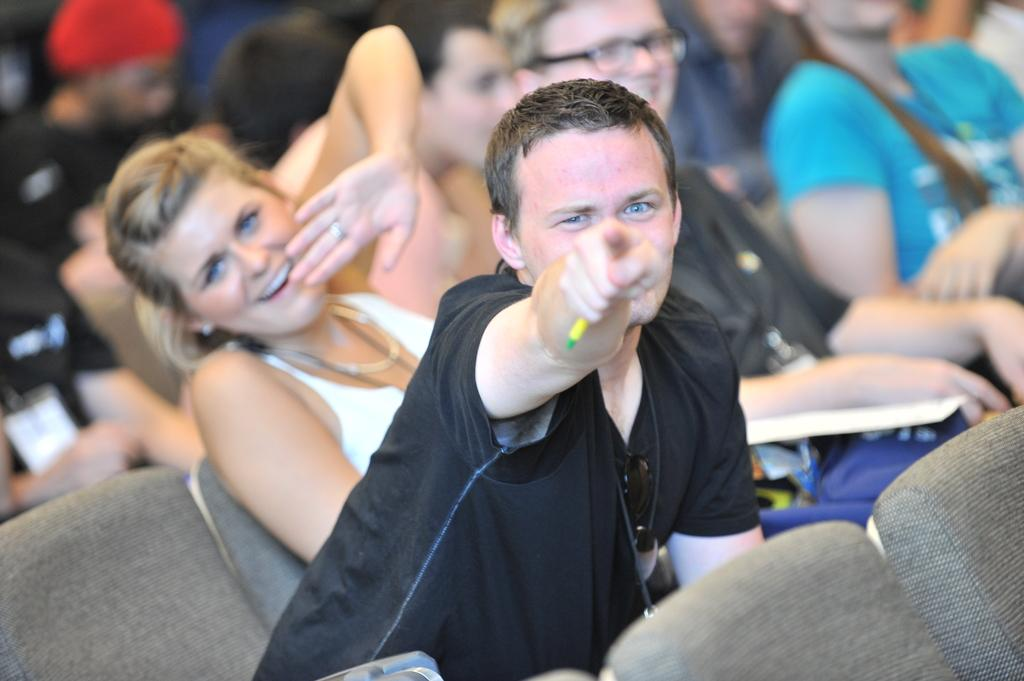What are the people in the image doing? The people in the image are sitting on chairs. Can you describe the action of the person in the front? The person in the front is pointing his finger towards something. What type of beef is being served at the vacation spot in the image? There is no mention of beef or a vacation spot in the image; it only shows people sitting on chairs and a person pointing his finger. 